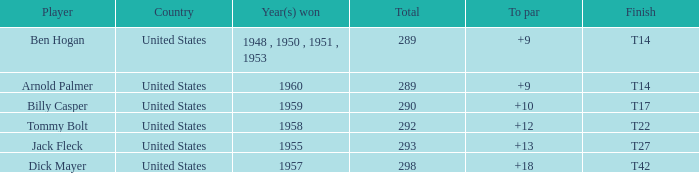What is Country, when Total is less than 290, and when Year(s) Won is 1960? United States. 